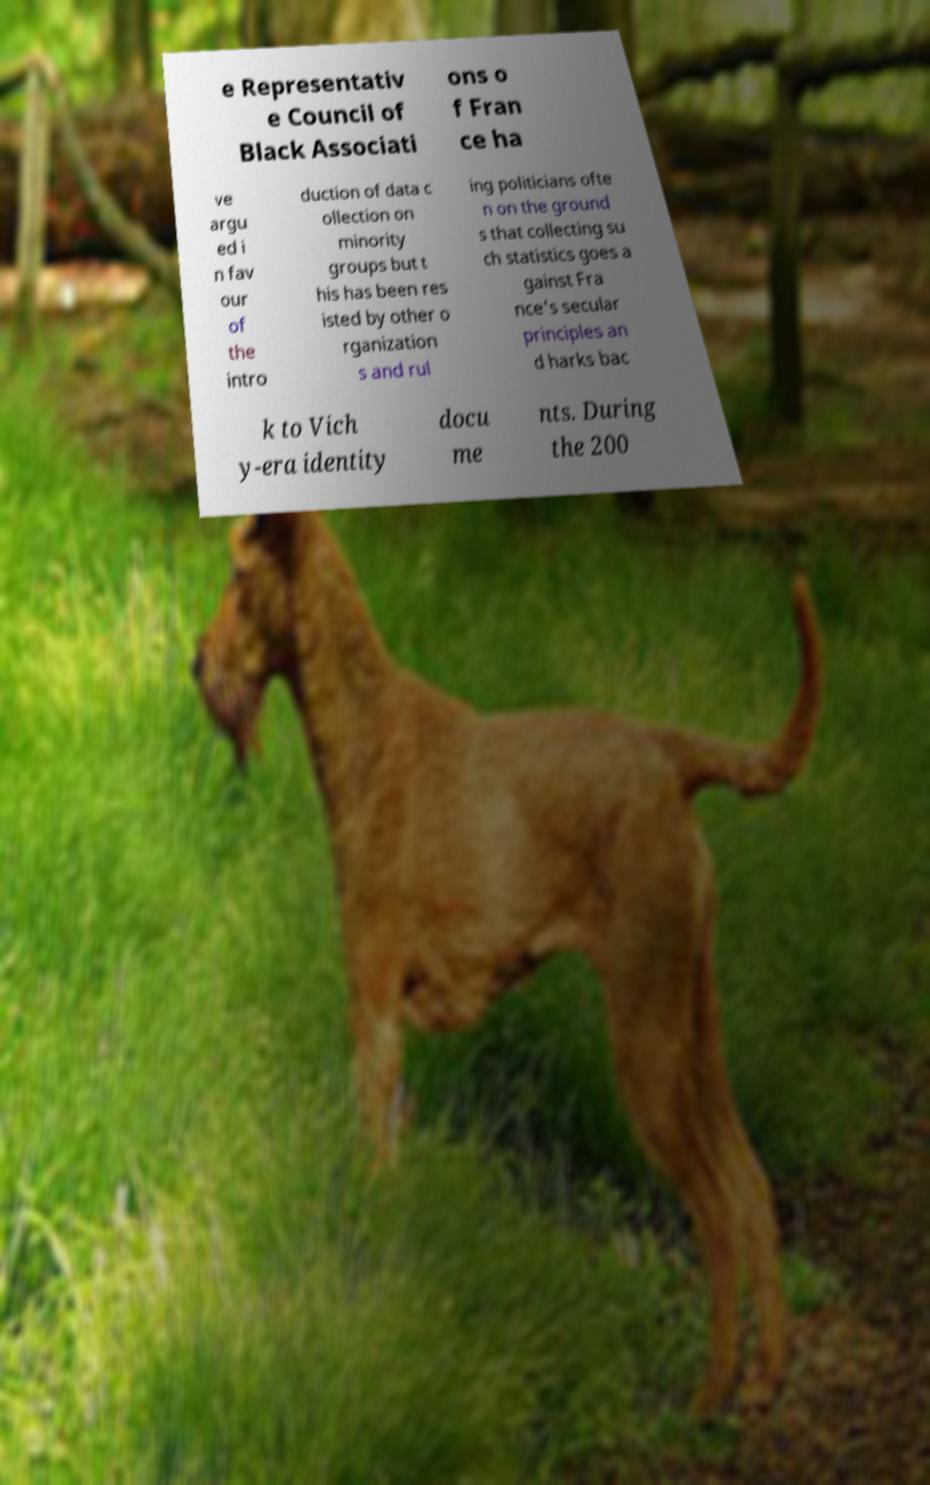What messages or text are displayed in this image? I need them in a readable, typed format. e Representativ e Council of Black Associati ons o f Fran ce ha ve argu ed i n fav our of the intro duction of data c ollection on minority groups but t his has been res isted by other o rganization s and rul ing politicians ofte n on the ground s that collecting su ch statistics goes a gainst Fra nce's secular principles an d harks bac k to Vich y-era identity docu me nts. During the 200 